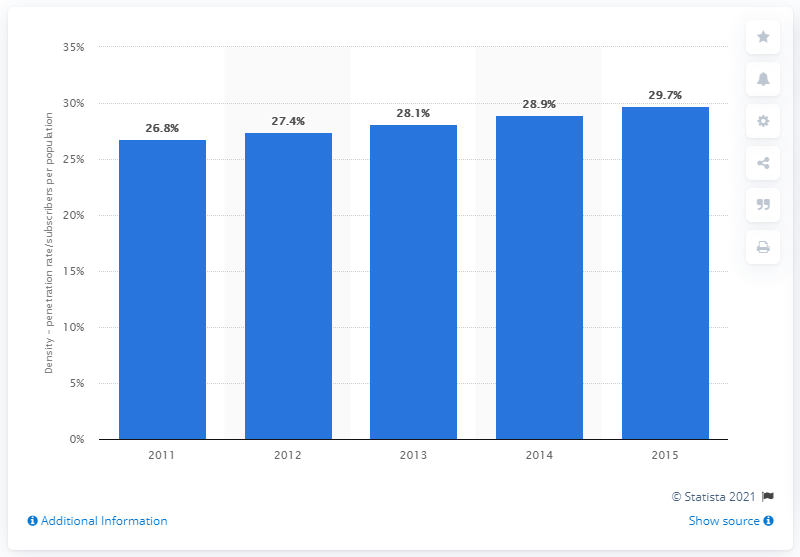List a handful of essential elements in this visual. In 2014, the internet density in Europe was 28.9%. 